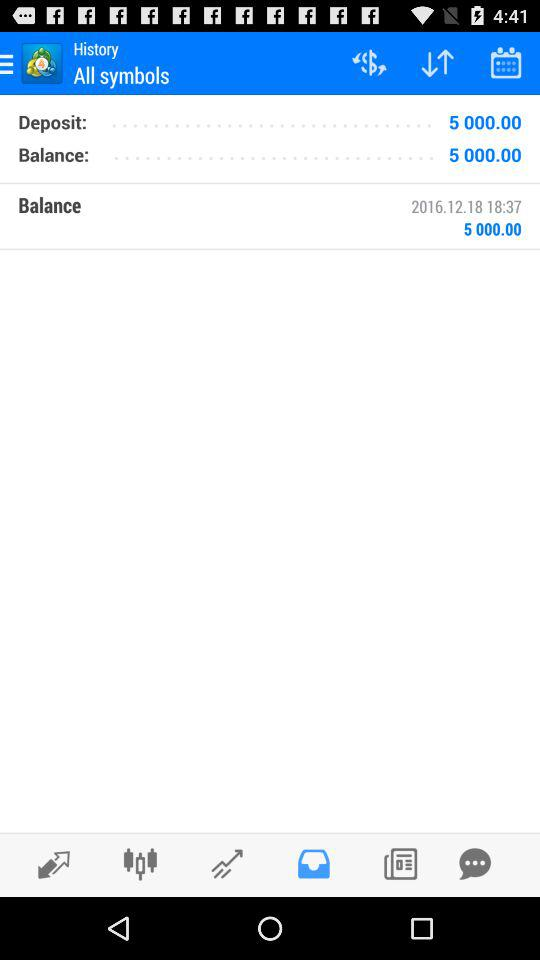What is the date and time of the last transaction?
Answer the question using a single word or phrase. 2016.12.18 18:37 